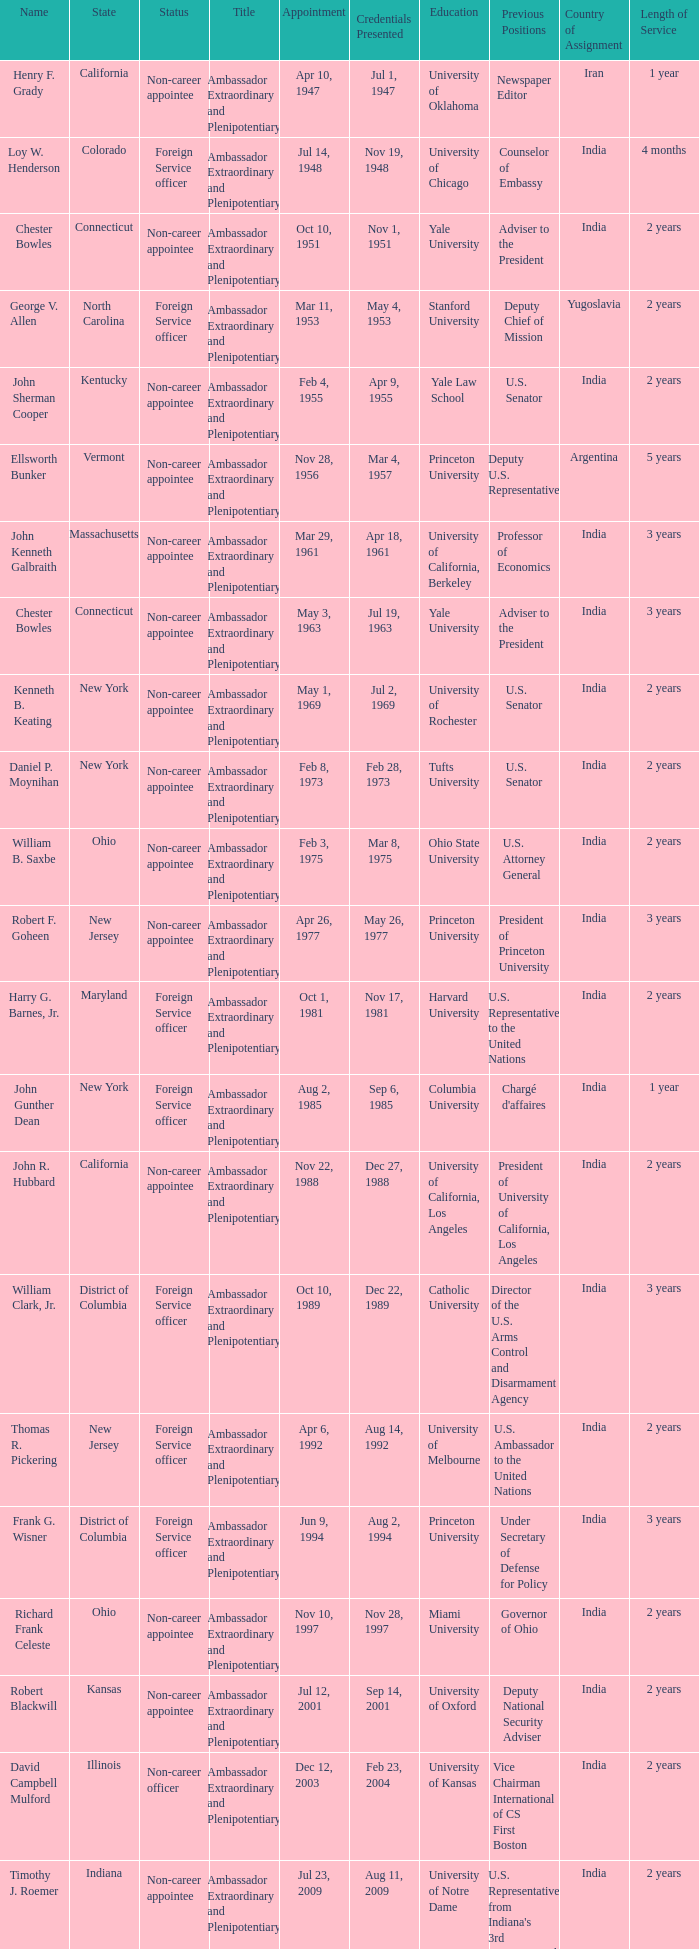What day were credentials presented for vermont? Mar 4, 1957. Can you give me this table as a dict? {'header': ['Name', 'State', 'Status', 'Title', 'Appointment', 'Credentials Presented', 'Education', 'Previous Positions', 'Country of Assignment', 'Length of Service'], 'rows': [['Henry F. Grady', 'California', 'Non-career appointee', 'Ambassador Extraordinary and Plenipotentiary', 'Apr 10, 1947', 'Jul 1, 1947', 'University of Oklahoma', 'Newspaper Editor', 'Iran', '1 year'], ['Loy W. Henderson', 'Colorado', 'Foreign Service officer', 'Ambassador Extraordinary and Plenipotentiary', 'Jul 14, 1948', 'Nov 19, 1948', 'University of Chicago', 'Counselor of Embassy', 'India', '4 months'], ['Chester Bowles', 'Connecticut', 'Non-career appointee', 'Ambassador Extraordinary and Plenipotentiary', 'Oct 10, 1951', 'Nov 1, 1951', 'Yale University', 'Adviser to the President', 'India', '2 years'], ['George V. Allen', 'North Carolina', 'Foreign Service officer', 'Ambassador Extraordinary and Plenipotentiary', 'Mar 11, 1953', 'May 4, 1953', 'Stanford University', 'Deputy Chief of Mission', 'Yugoslavia', '2 years'], ['John Sherman Cooper', 'Kentucky', 'Non-career appointee', 'Ambassador Extraordinary and Plenipotentiary', 'Feb 4, 1955', 'Apr 9, 1955', 'Yale Law School', 'U.S. Senator', 'India', '2 years'], ['Ellsworth Bunker', 'Vermont', 'Non-career appointee', 'Ambassador Extraordinary and Plenipotentiary', 'Nov 28, 1956', 'Mar 4, 1957', 'Princeton University', 'Deputy U.S. Representative', 'Argentina', '5 years'], ['John Kenneth Galbraith', 'Massachusetts', 'Non-career appointee', 'Ambassador Extraordinary and Plenipotentiary', 'Mar 29, 1961', 'Apr 18, 1961', 'University of California, Berkeley', 'Professor of Economics', 'India', '3 years'], ['Chester Bowles', 'Connecticut', 'Non-career appointee', 'Ambassador Extraordinary and Plenipotentiary', 'May 3, 1963', 'Jul 19, 1963', 'Yale University', 'Adviser to the President', 'India', '3 years'], ['Kenneth B. Keating', 'New York', 'Non-career appointee', 'Ambassador Extraordinary and Plenipotentiary', 'May 1, 1969', 'Jul 2, 1969', 'University of Rochester', 'U.S. Senator', 'India', '2 years'], ['Daniel P. Moynihan', 'New York', 'Non-career appointee', 'Ambassador Extraordinary and Plenipotentiary', 'Feb 8, 1973', 'Feb 28, 1973', 'Tufts University', 'U.S. Senator', 'India', '2 years'], ['William B. Saxbe', 'Ohio', 'Non-career appointee', 'Ambassador Extraordinary and Plenipotentiary', 'Feb 3, 1975', 'Mar 8, 1975', 'Ohio State University', 'U.S. Attorney General', 'India', '2 years'], ['Robert F. Goheen', 'New Jersey', 'Non-career appointee', 'Ambassador Extraordinary and Plenipotentiary', 'Apr 26, 1977', 'May 26, 1977', 'Princeton University', 'President of Princeton University', 'India', '3 years'], ['Harry G. Barnes, Jr.', 'Maryland', 'Foreign Service officer', 'Ambassador Extraordinary and Plenipotentiary', 'Oct 1, 1981', 'Nov 17, 1981', 'Harvard University', 'U.S. Representative to the United Nations', 'India', '2 years'], ['John Gunther Dean', 'New York', 'Foreign Service officer', 'Ambassador Extraordinary and Plenipotentiary', 'Aug 2, 1985', 'Sep 6, 1985', 'Columbia University', "Chargé d'affaires", 'India', '1 year'], ['John R. Hubbard', 'California', 'Non-career appointee', 'Ambassador Extraordinary and Plenipotentiary', 'Nov 22, 1988', 'Dec 27, 1988', 'University of California, Los Angeles', 'President of University of California, Los Angeles', 'India', '2 years'], ['William Clark, Jr.', 'District of Columbia', 'Foreign Service officer', 'Ambassador Extraordinary and Plenipotentiary', 'Oct 10, 1989', 'Dec 22, 1989', 'Catholic University', 'Director of the U.S. Arms Control and Disarmament Agency', 'India', '3 years'], ['Thomas R. Pickering', 'New Jersey', 'Foreign Service officer', 'Ambassador Extraordinary and Plenipotentiary', 'Apr 6, 1992', 'Aug 14, 1992', 'University of Melbourne', 'U.S. Ambassador to the United Nations', 'India', '2 years'], ['Frank G. Wisner', 'District of Columbia', 'Foreign Service officer', 'Ambassador Extraordinary and Plenipotentiary', 'Jun 9, 1994', 'Aug 2, 1994', 'Princeton University', 'Under Secretary of Defense for Policy', 'India', '3 years'], ['Richard Frank Celeste', 'Ohio', 'Non-career appointee', 'Ambassador Extraordinary and Plenipotentiary', 'Nov 10, 1997', 'Nov 28, 1997', 'Miami University', 'Governor of Ohio', 'India', '2 years'], ['Robert Blackwill', 'Kansas', 'Non-career appointee', 'Ambassador Extraordinary and Plenipotentiary', 'Jul 12, 2001', 'Sep 14, 2001', 'University of Oxford', 'Deputy National Security Adviser', 'India', '2 years'], ['David Campbell Mulford', 'Illinois', 'Non-career officer', 'Ambassador Extraordinary and Plenipotentiary', 'Dec 12, 2003', 'Feb 23, 2004', 'University of Kansas', 'Vice Chairman International of CS First Boston', 'India', '2 years'], ['Timothy J. Roemer', 'Indiana', 'Non-career appointee', 'Ambassador Extraordinary and Plenipotentiary', 'Jul 23, 2009', 'Aug 11, 2009', 'University of Notre Dame', "U.S. Representative from Indiana's 3rd Congressional District", 'India', '2 years'], ['Albert Peter Burleigh', 'California', 'Foreign Service officer', "Charge d'affaires", 'June 2011', 'Left post 2012', 'University of Mississippi', 'Deputy Chief of Mission', 'India', '1 year'], ['Nancy Jo Powell', 'Iowa', 'Foreign Service officer', 'Ambassador Extraordinary and Plenipotentiary', 'February 7, 2012', 'April 19, 2012', 'University of Northern Iowa', 'Director General of the Foreign Service and Director of Human Resources', 'India', '2 years']]} 